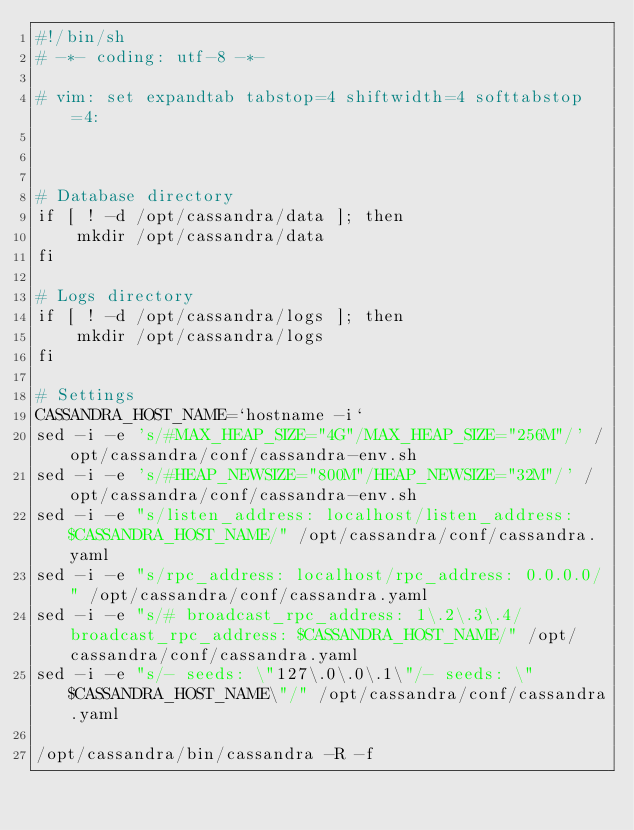<code> <loc_0><loc_0><loc_500><loc_500><_Bash_>#!/bin/sh
# -*- coding: utf-8 -*-

# vim: set expandtab tabstop=4 shiftwidth=4 softtabstop=4:



# Database directory
if [ ! -d /opt/cassandra/data ]; then
    mkdir /opt/cassandra/data
fi

# Logs directory
if [ ! -d /opt/cassandra/logs ]; then
    mkdir /opt/cassandra/logs
fi

# Settings
CASSANDRA_HOST_NAME=`hostname -i`
sed -i -e 's/#MAX_HEAP_SIZE="4G"/MAX_HEAP_SIZE="256M"/' /opt/cassandra/conf/cassandra-env.sh
sed -i -e 's/#HEAP_NEWSIZE="800M"/HEAP_NEWSIZE="32M"/' /opt/cassandra/conf/cassandra-env.sh
sed -i -e "s/listen_address: localhost/listen_address: $CASSANDRA_HOST_NAME/" /opt/cassandra/conf/cassandra.yaml
sed -i -e "s/rpc_address: localhost/rpc_address: 0.0.0.0/" /opt/cassandra/conf/cassandra.yaml
sed -i -e "s/# broadcast_rpc_address: 1\.2\.3\.4/broadcast_rpc_address: $CASSANDRA_HOST_NAME/" /opt/cassandra/conf/cassandra.yaml
sed -i -e "s/- seeds: \"127\.0\.0\.1\"/- seeds: \"$CASSANDRA_HOST_NAME\"/" /opt/cassandra/conf/cassandra.yaml

/opt/cassandra/bin/cassandra -R -f


</code> 